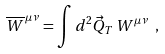Convert formula to latex. <formula><loc_0><loc_0><loc_500><loc_500>\overline { W } ^ { \, \mu \nu } = \int d ^ { 2 } \vec { Q } _ { T } \, W ^ { \mu \nu } \ ,</formula> 